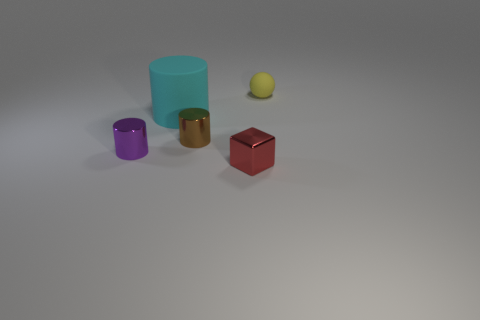Could you describe the lighting in the image? The lighting in the image is relatively soft and diffused, coming from a direction slightly off to the side. This is evidenced by the gentle shadows cast on the right side of the objects, suggesting the light source is to the left of the image frame. There are no harsh or strong highlights, indicating the light source may be large or filtered to create such soft illumination. 